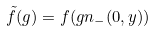<formula> <loc_0><loc_0><loc_500><loc_500>\tilde { f } ( g ) = f ( g n _ { - } ( 0 , y ) )</formula> 